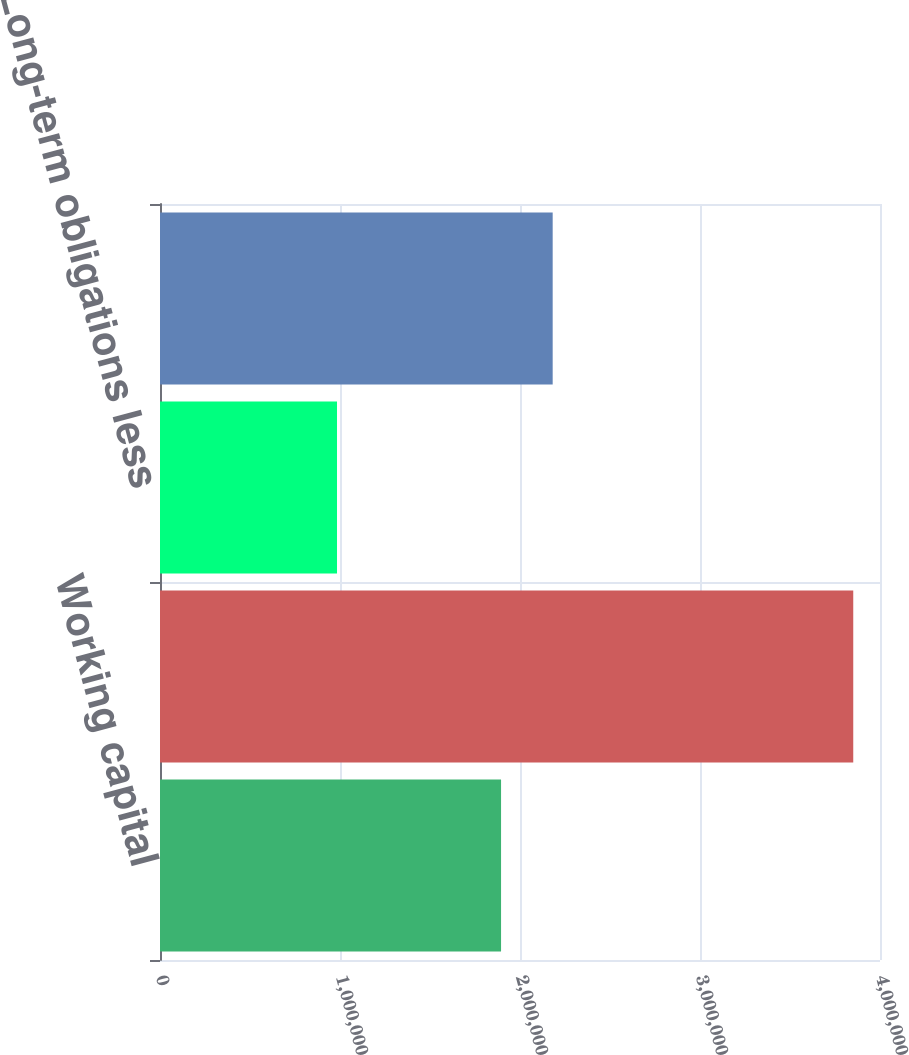<chart> <loc_0><loc_0><loc_500><loc_500><bar_chart><fcel>Working capital<fcel>Total assets<fcel>Long-term obligations less<fcel>Microchip Technology<nl><fcel>1.89476e+06<fcel>3.8514e+06<fcel>983385<fcel>2.18156e+06<nl></chart> 